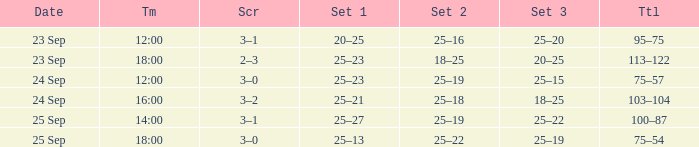What was the score when the time was 14:00? 3–1. 